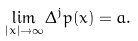Convert formula to latex. <formula><loc_0><loc_0><loc_500><loc_500>\lim _ { | x | \to \infty } \Delta ^ { j } p ( x ) = a .</formula> 